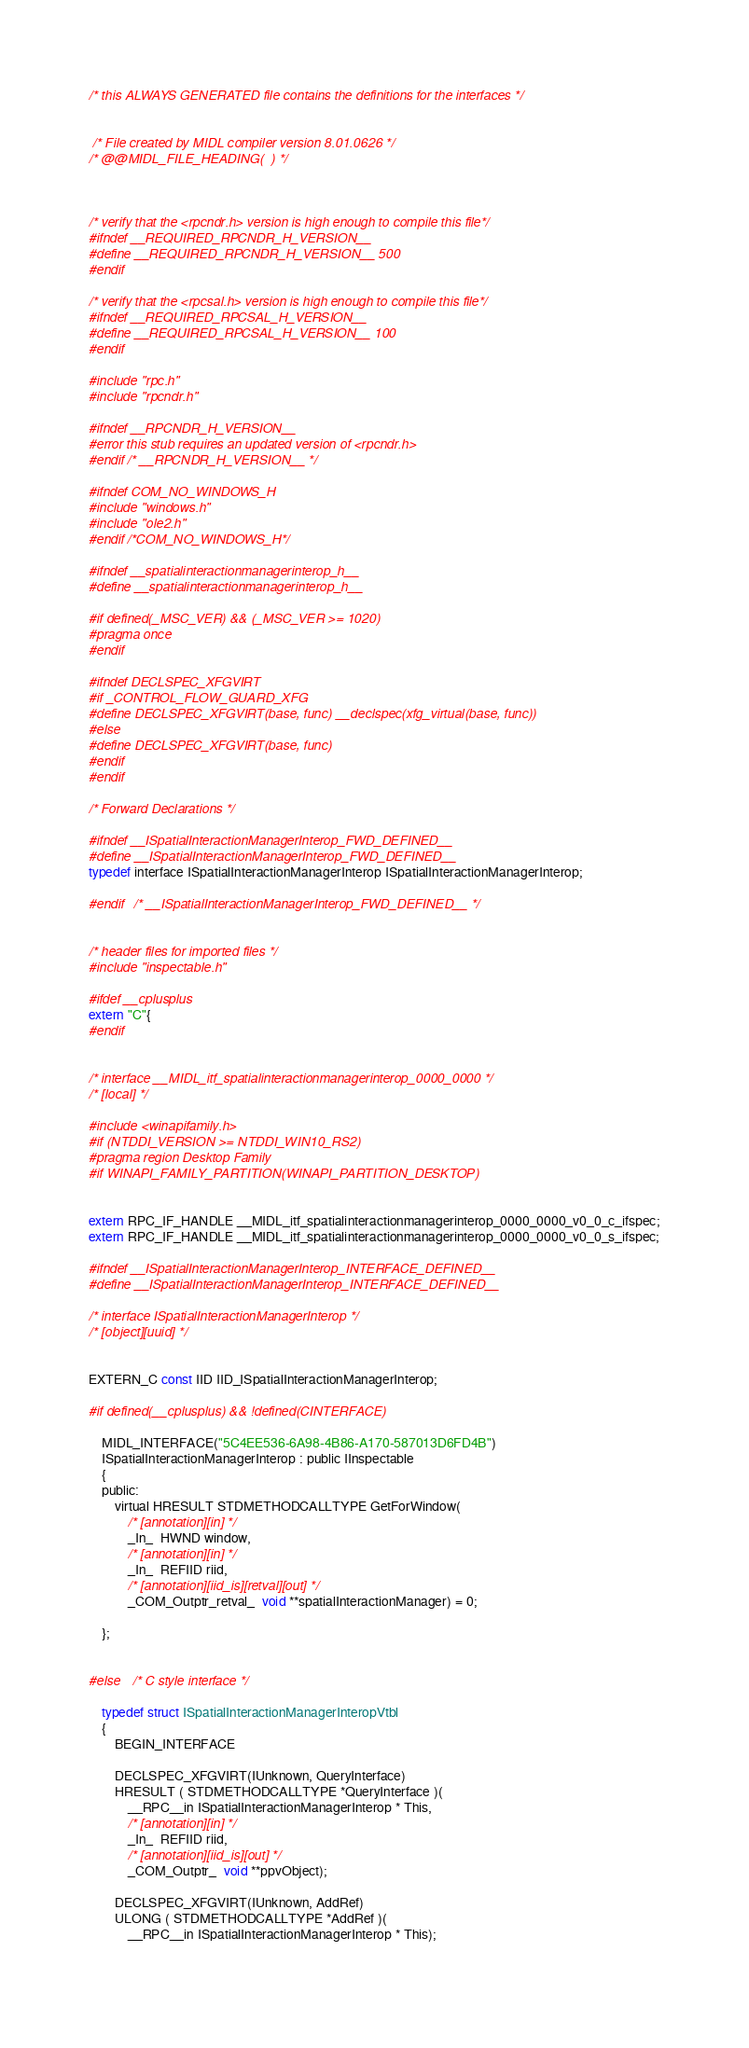<code> <loc_0><loc_0><loc_500><loc_500><_C_>

/* this ALWAYS GENERATED file contains the definitions for the interfaces */


 /* File created by MIDL compiler version 8.01.0626 */
/* @@MIDL_FILE_HEADING(  ) */



/* verify that the <rpcndr.h> version is high enough to compile this file*/
#ifndef __REQUIRED_RPCNDR_H_VERSION__
#define __REQUIRED_RPCNDR_H_VERSION__ 500
#endif

/* verify that the <rpcsal.h> version is high enough to compile this file*/
#ifndef __REQUIRED_RPCSAL_H_VERSION__
#define __REQUIRED_RPCSAL_H_VERSION__ 100
#endif

#include "rpc.h"
#include "rpcndr.h"

#ifndef __RPCNDR_H_VERSION__
#error this stub requires an updated version of <rpcndr.h>
#endif /* __RPCNDR_H_VERSION__ */

#ifndef COM_NO_WINDOWS_H
#include "windows.h"
#include "ole2.h"
#endif /*COM_NO_WINDOWS_H*/

#ifndef __spatialinteractionmanagerinterop_h__
#define __spatialinteractionmanagerinterop_h__

#if defined(_MSC_VER) && (_MSC_VER >= 1020)
#pragma once
#endif

#ifndef DECLSPEC_XFGVIRT
#if _CONTROL_FLOW_GUARD_XFG
#define DECLSPEC_XFGVIRT(base, func) __declspec(xfg_virtual(base, func))
#else
#define DECLSPEC_XFGVIRT(base, func)
#endif
#endif

/* Forward Declarations */ 

#ifndef __ISpatialInteractionManagerInterop_FWD_DEFINED__
#define __ISpatialInteractionManagerInterop_FWD_DEFINED__
typedef interface ISpatialInteractionManagerInterop ISpatialInteractionManagerInterop;

#endif 	/* __ISpatialInteractionManagerInterop_FWD_DEFINED__ */


/* header files for imported files */
#include "inspectable.h"

#ifdef __cplusplus
extern "C"{
#endif 


/* interface __MIDL_itf_spatialinteractionmanagerinterop_0000_0000 */
/* [local] */ 

#include <winapifamily.h>
#if (NTDDI_VERSION >= NTDDI_WIN10_RS2)
#pragma region Desktop Family
#if WINAPI_FAMILY_PARTITION(WINAPI_PARTITION_DESKTOP)


extern RPC_IF_HANDLE __MIDL_itf_spatialinteractionmanagerinterop_0000_0000_v0_0_c_ifspec;
extern RPC_IF_HANDLE __MIDL_itf_spatialinteractionmanagerinterop_0000_0000_v0_0_s_ifspec;

#ifndef __ISpatialInteractionManagerInterop_INTERFACE_DEFINED__
#define __ISpatialInteractionManagerInterop_INTERFACE_DEFINED__

/* interface ISpatialInteractionManagerInterop */
/* [object][uuid] */ 


EXTERN_C const IID IID_ISpatialInteractionManagerInterop;

#if defined(__cplusplus) && !defined(CINTERFACE)
    
    MIDL_INTERFACE("5C4EE536-6A98-4B86-A170-587013D6FD4B")
    ISpatialInteractionManagerInterop : public IInspectable
    {
    public:
        virtual HRESULT STDMETHODCALLTYPE GetForWindow( 
            /* [annotation][in] */ 
            _In_  HWND window,
            /* [annotation][in] */ 
            _In_  REFIID riid,
            /* [annotation][iid_is][retval][out] */ 
            _COM_Outptr_retval_  void **spatialInteractionManager) = 0;
        
    };
    
    
#else 	/* C style interface */

    typedef struct ISpatialInteractionManagerInteropVtbl
    {
        BEGIN_INTERFACE
        
        DECLSPEC_XFGVIRT(IUnknown, QueryInterface)
        HRESULT ( STDMETHODCALLTYPE *QueryInterface )( 
            __RPC__in ISpatialInteractionManagerInterop * This,
            /* [annotation][in] */ 
            _In_  REFIID riid,
            /* [annotation][iid_is][out] */ 
            _COM_Outptr_  void **ppvObject);
        
        DECLSPEC_XFGVIRT(IUnknown, AddRef)
        ULONG ( STDMETHODCALLTYPE *AddRef )( 
            __RPC__in ISpatialInteractionManagerInterop * This);
        </code> 